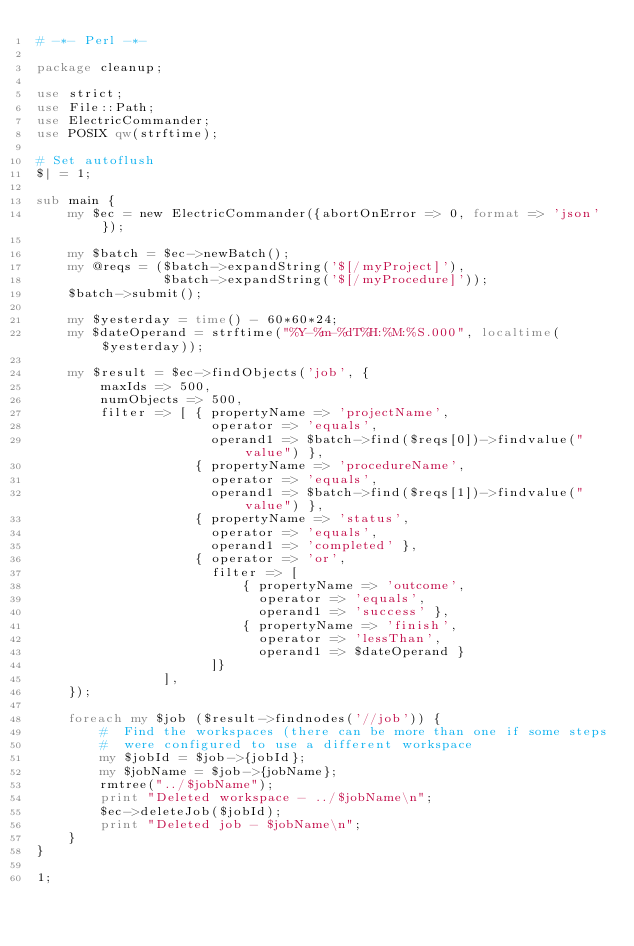Convert code to text. <code><loc_0><loc_0><loc_500><loc_500><_Perl_># -*- Perl -*-

package cleanup;

use strict;
use File::Path;
use ElectricCommander;
use POSIX qw(strftime);

# Set autoflush
$| = 1;

sub main {
    my $ec = new ElectricCommander({abortOnError => 0, format => 'json'});

    my $batch = $ec->newBatch();
    my @reqs = ($batch->expandString('$[/myProject]'),
                $batch->expandString('$[/myProcedure]'));
    $batch->submit();

    my $yesterday = time() - 60*60*24;
    my $dateOperand = strftime("%Y-%m-%dT%H:%M:%S.000", localtime($yesterday));

    my $result = $ec->findObjects('job', {
        maxIds => 500,
        numObjects => 500,
        filter => [ { propertyName => 'projectName',
                      operator => 'equals',
                      operand1 => $batch->find($reqs[0])->findvalue("value") },
                    { propertyName => 'procedureName',
                      operator => 'equals',
                      operand1 => $batch->find($reqs[1])->findvalue("value") },
                    { propertyName => 'status',
                      operator => 'equals',
                      operand1 => 'completed' },
                    { operator => 'or',
                      filter => [
                          { propertyName => 'outcome',
                            operator => 'equals',
                            operand1 => 'success' },
                          { propertyName => 'finish',
                            operator => 'lessThan',
                            operand1 => $dateOperand }
                      ]}
                ],
    });

    foreach my $job ($result->findnodes('//job')) {
        #  Find the workspaces (there can be more than one if some steps
        #  were configured to use a different workspace
        my $jobId = $job->{jobId};
        my $jobName = $job->{jobName};
        rmtree("../$jobName");
        print "Deleted workspace - ../$jobName\n";
        $ec->deleteJob($jobId);
        print "Deleted job - $jobName\n";
    }
}

1;

</code> 